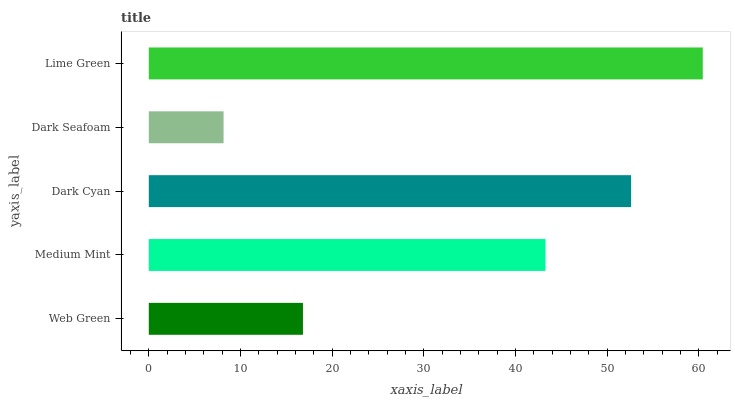Is Dark Seafoam the minimum?
Answer yes or no. Yes. Is Lime Green the maximum?
Answer yes or no. Yes. Is Medium Mint the minimum?
Answer yes or no. No. Is Medium Mint the maximum?
Answer yes or no. No. Is Medium Mint greater than Web Green?
Answer yes or no. Yes. Is Web Green less than Medium Mint?
Answer yes or no. Yes. Is Web Green greater than Medium Mint?
Answer yes or no. No. Is Medium Mint less than Web Green?
Answer yes or no. No. Is Medium Mint the high median?
Answer yes or no. Yes. Is Medium Mint the low median?
Answer yes or no. Yes. Is Lime Green the high median?
Answer yes or no. No. Is Lime Green the low median?
Answer yes or no. No. 